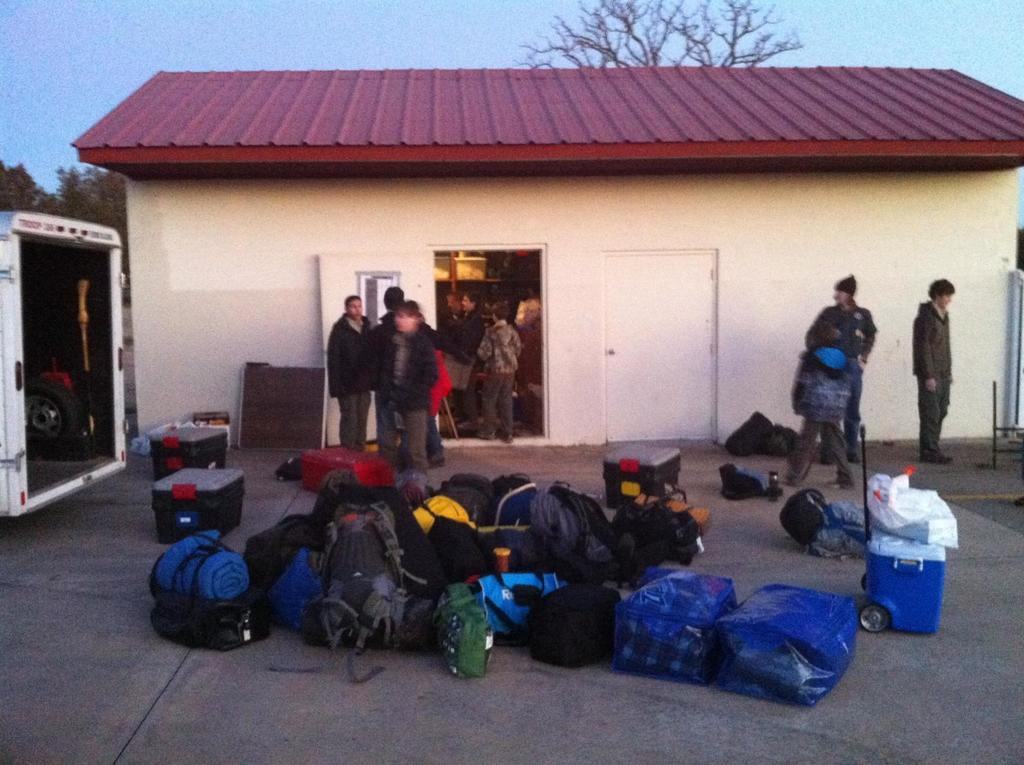What objects are on the surface in the image? There are bags and boxes on the surface in the image. Who or what can be seen in the image? There are people in the image. What type of structure is present in the image? There is a house in the image. What mode of transportation is visible in the image? There is a vehicle in the image. What architectural features can be seen in the image? There are doors in the image. What can be seen in the background of the image? There are trees and the sky visible in the background of the image. What type of knife is being used to cut the pie in the image? There is no knife or pie present in the image. 